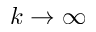<formula> <loc_0><loc_0><loc_500><loc_500>k \rightarrow \infty</formula> 